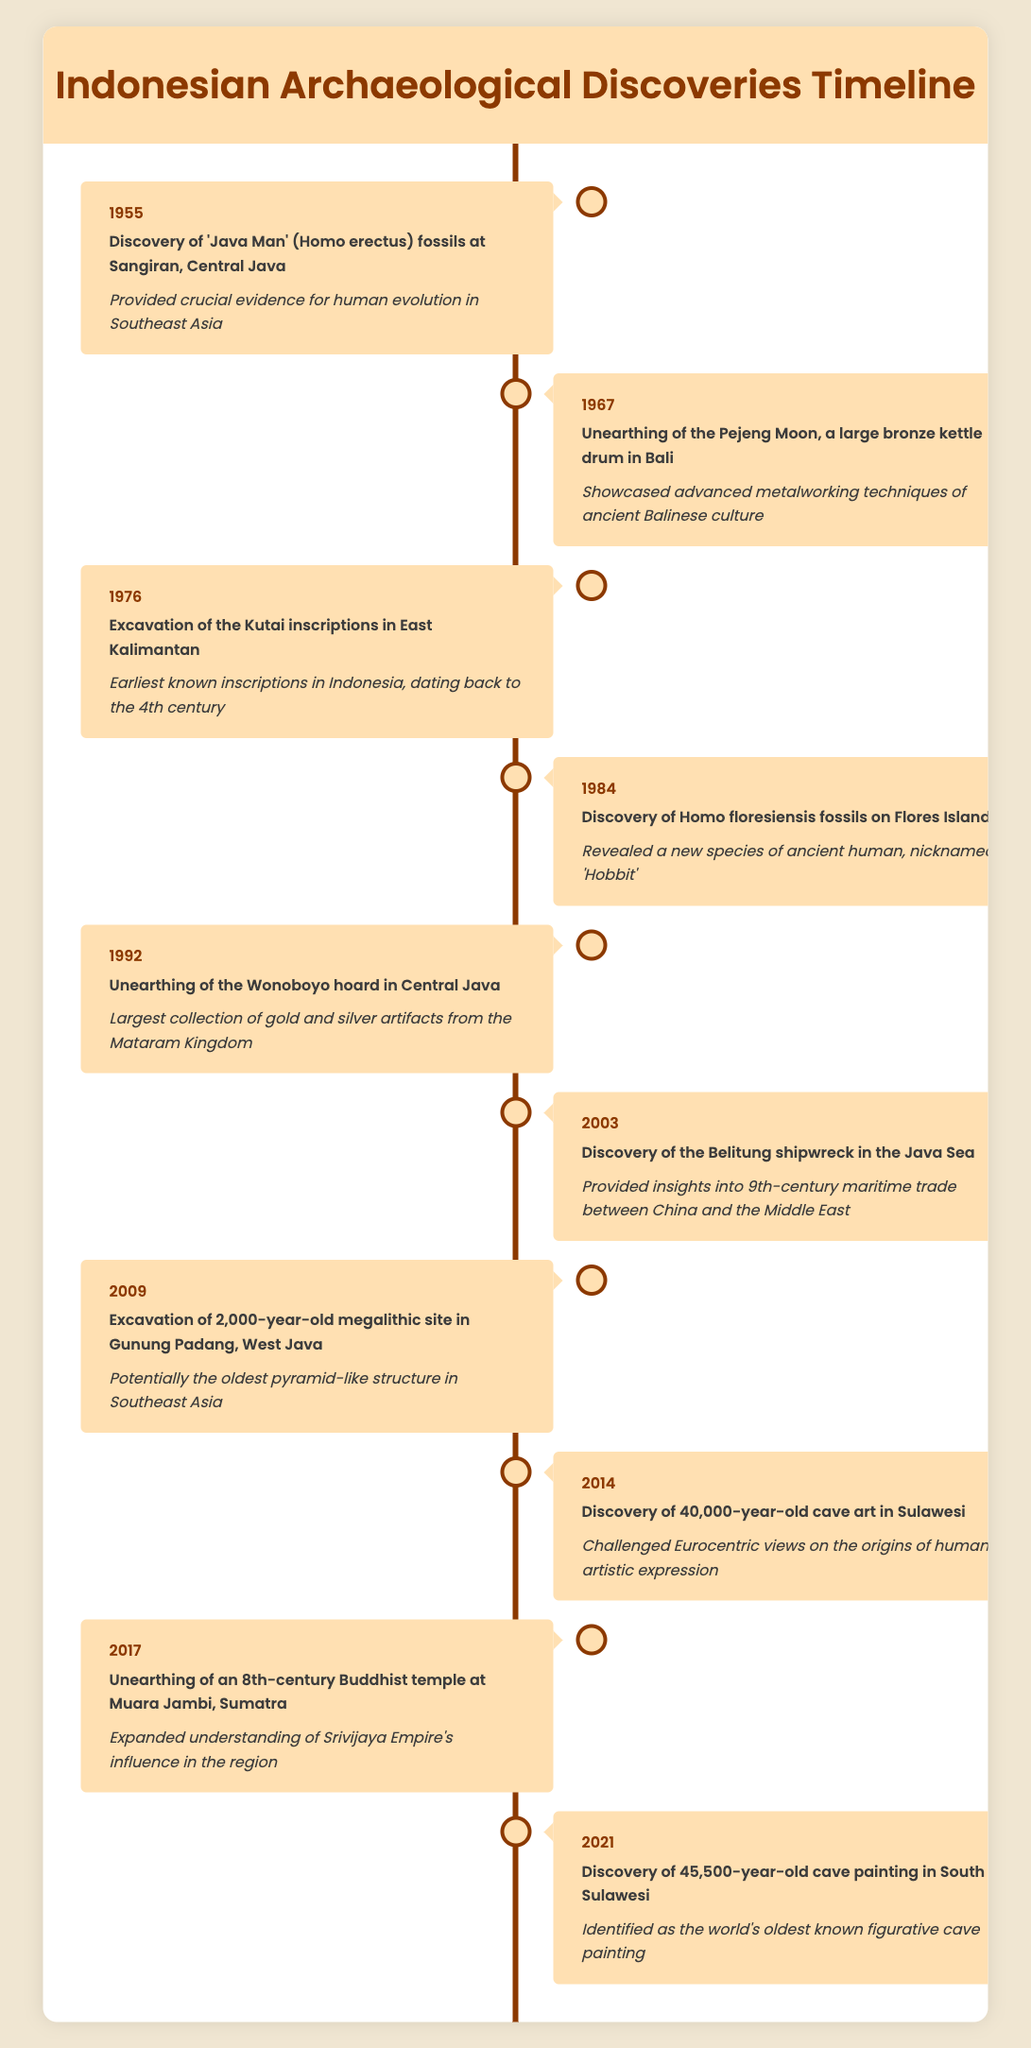What significant archaeological discovery occurred in 1984? In 1984, the discovery of Homo floresiensis fossils on Flores Island was made. This event is significant because it revealed a new species of ancient human, which is colloquially referred to as 'Hobbit'.
Answer: Discovery of Homo floresiensis fossils on Flores Island Which discovery is the oldest in the timeline? The timeline starts in 1955, and the discovery of 'Java Man' (Homo erectus) fossils at Sangiran, Central Java, occurred that year. Therefore, the oldest discovery listed is the one from 1955.
Answer: Discovery of 'Java Man' fossils in 1955 Is the Pejeng Moon associated with advanced metalworking techniques? Yes, the unearthing of the Pejeng Moon in 1967 showcased advanced metalworking techniques of the ancient Balinese culture. Therefore, the statement is true.
Answer: Yes How many significant events related to cave art are mentioned? There are two events related to cave art in the timeline: the discovery of 40,000-year-old cave art in Sulawesi (2014) and the 45,500-year-old cave painting in South Sulawesi (2021). To find the total, we can count the events specifically mentioning cave art. Therefore, 2 events are noted.
Answer: 2 What year had the largest collection of artifacts discovered? In 1992, the unearthing of the Wonoboyo hoard occurred, which is the largest collection of gold and silver artifacts from the Mataram Kingdom. To find this, one can refer to the event descriptions and identify the relevant details.
Answer: 1992 Which discovery provides insights into maritime trade? The discovery of the Belitung shipwreck in the Java Sea in 2003 provided insights into 9th-century maritime trade between China and the Middle East. Thus, the event associated with maritime trade is in 2003.
Answer: Discovery of the Belitung shipwreck in 2003 What was the significance of the excavated megalithic site in 2009? The excavation of the 2,000-year-old megalithic site in Gunung Padang, West Java, is significant because it is potentially the oldest pyramid-like structure in Southeast Asia. Here, the word "potentially" indicates that further studies may confirm its designation.
Answer: Potentially the oldest pyramid-like structure How many events occurred in the 2000s? In total, there are four events listed in the 2000s: 2003 (Belitung shipwreck), 2009 (Gunung Padang site), 2014 (cave art), and 2017 (Buddhist temple). Adding these gives a total of four distinct archaeological events that occurred during this decade.
Answer: 4 